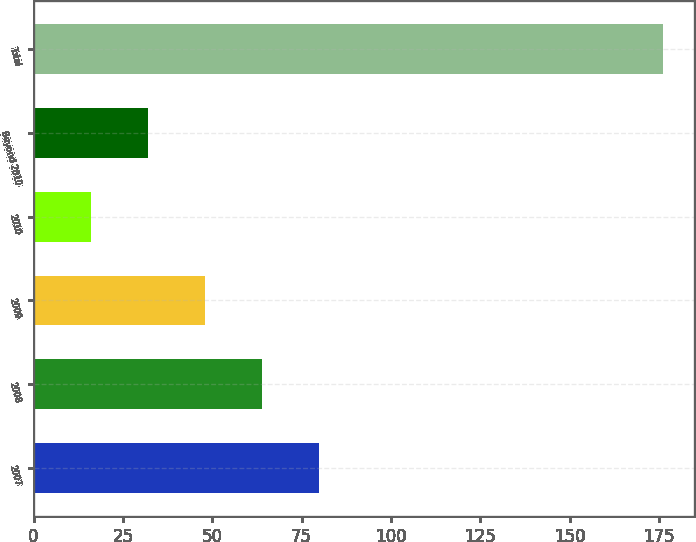Convert chart. <chart><loc_0><loc_0><loc_500><loc_500><bar_chart><fcel>2007<fcel>2008<fcel>2009<fcel>2010<fcel>Beyond 2010<fcel>Total<nl><fcel>80<fcel>64<fcel>48<fcel>16<fcel>32<fcel>176<nl></chart> 